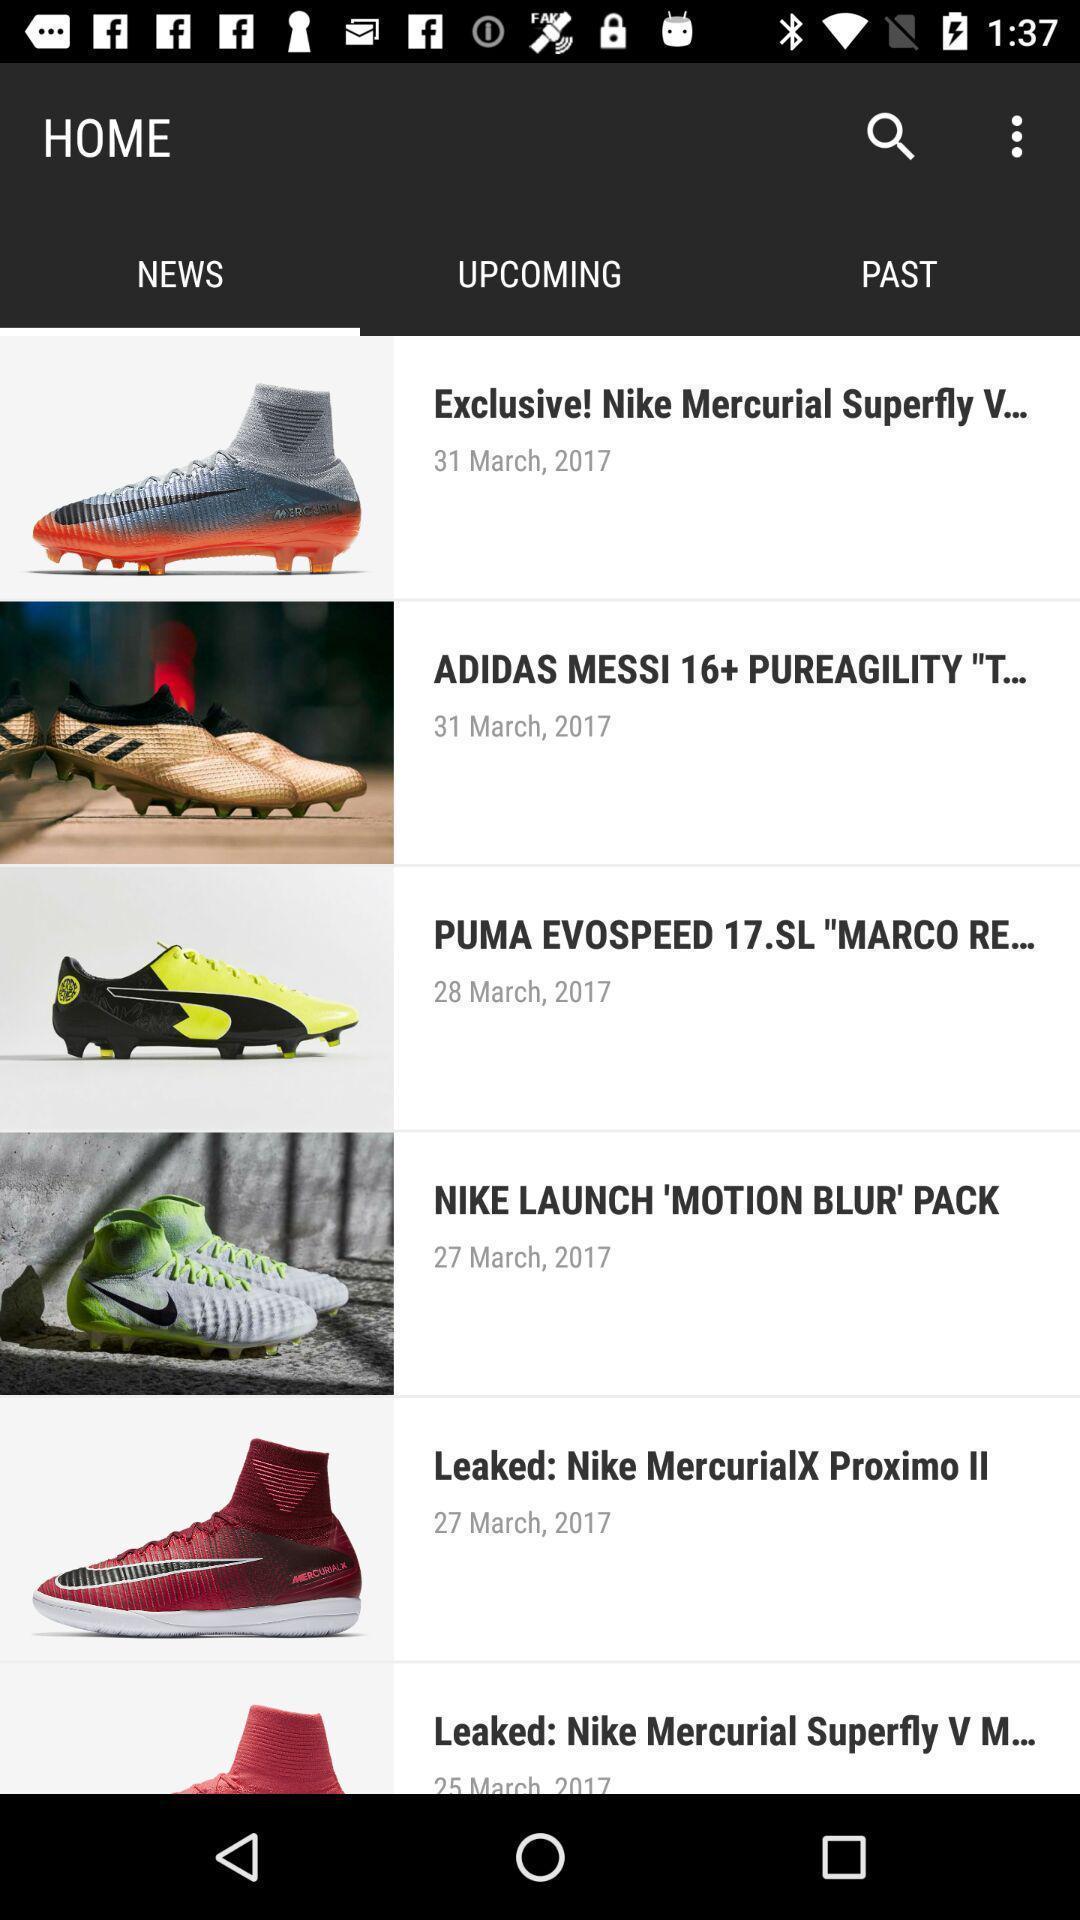Give me a summary of this screen capture. Screen shows news on soccer cleats. 